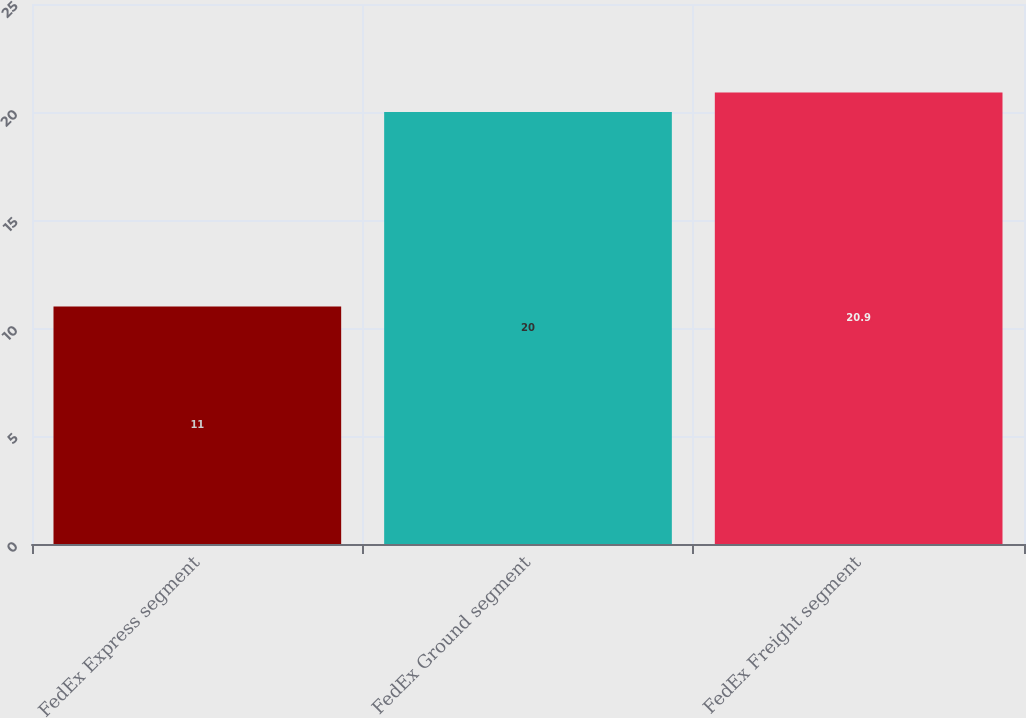Convert chart. <chart><loc_0><loc_0><loc_500><loc_500><bar_chart><fcel>FedEx Express segment<fcel>FedEx Ground segment<fcel>FedEx Freight segment<nl><fcel>11<fcel>20<fcel>20.9<nl></chart> 